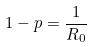<formula> <loc_0><loc_0><loc_500><loc_500>1 - p = \frac { 1 } { R _ { 0 } }</formula> 